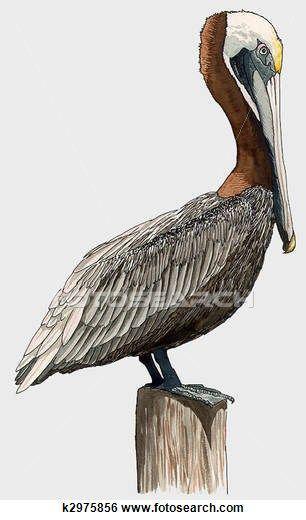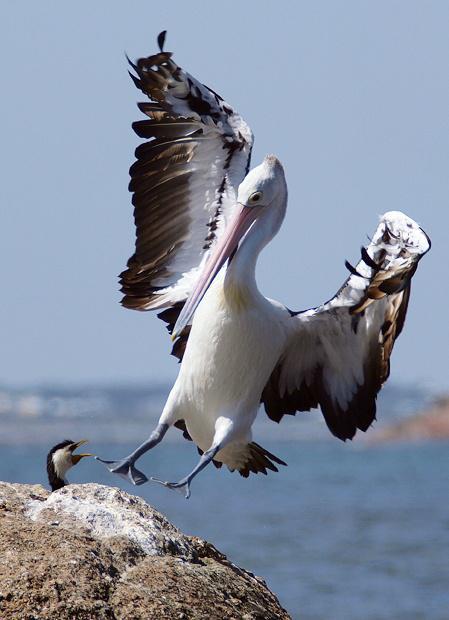The first image is the image on the left, the second image is the image on the right. Given the left and right images, does the statement "An image shows a single gliding pelican with wings extended." hold true? Answer yes or no. No. 